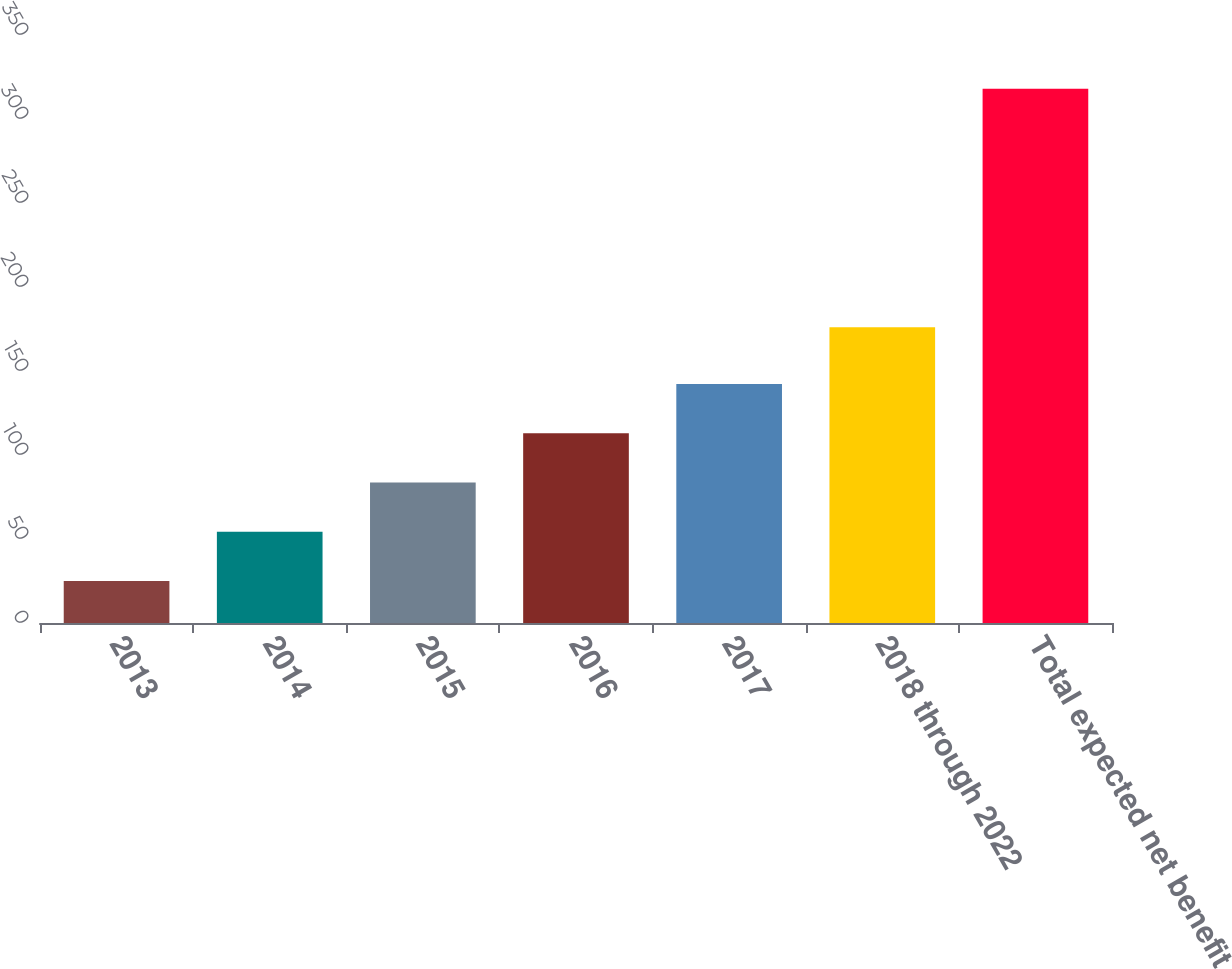Convert chart to OTSL. <chart><loc_0><loc_0><loc_500><loc_500><bar_chart><fcel>2013<fcel>2014<fcel>2015<fcel>2016<fcel>2017<fcel>2018 through 2022<fcel>Total expected net benefit<nl><fcel>25<fcel>54.3<fcel>83.6<fcel>112.9<fcel>142.2<fcel>176<fcel>318<nl></chart> 